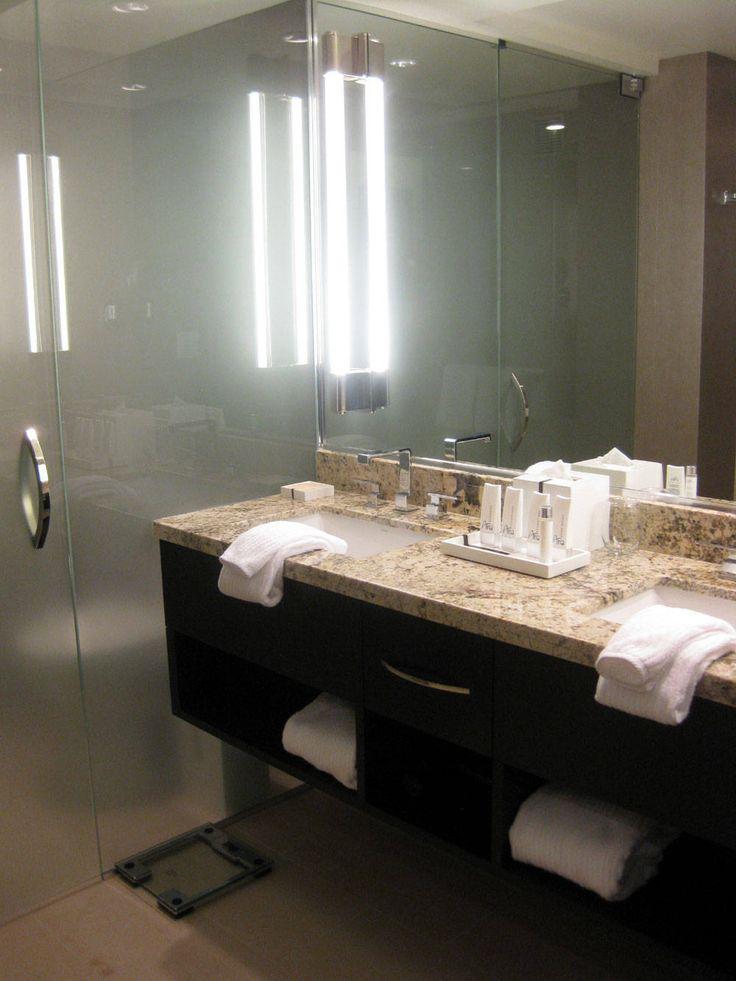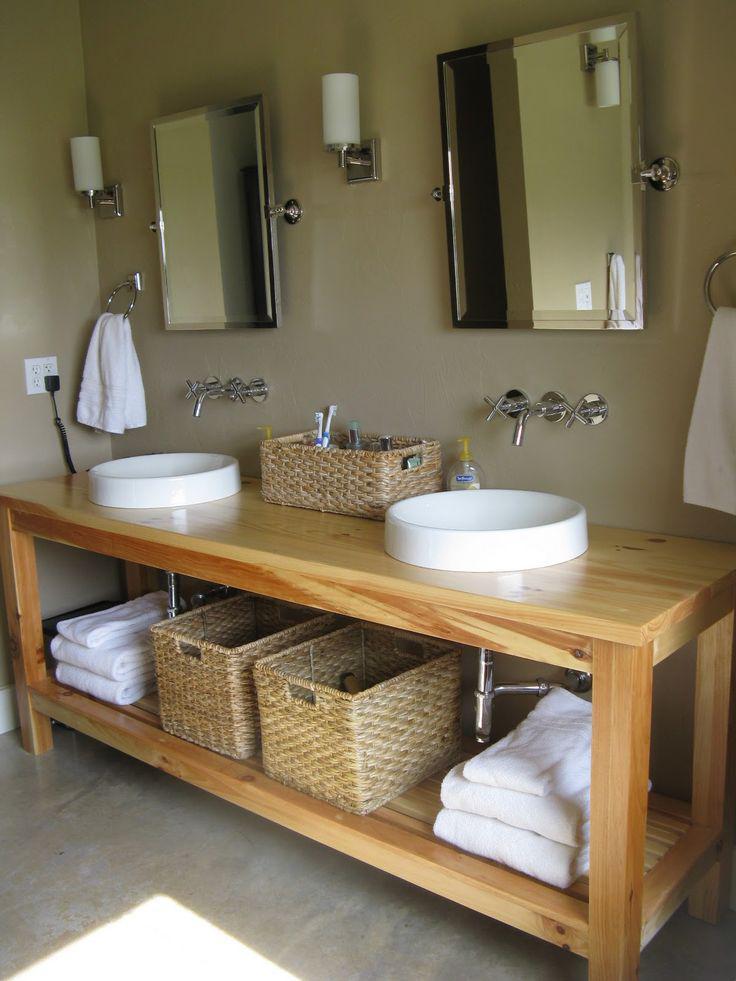The first image is the image on the left, the second image is the image on the right. For the images shown, is this caption "Left and right images each show one long counter with two separate sinks displayed at similar angles, and the counter on the right has at least one woven basket under it." true? Answer yes or no. Yes. The first image is the image on the left, the second image is the image on the right. Analyze the images presented: Is the assertion "In one image two vessel sinks are placed on a vanity with two stacks of white towels on a shelf below." valid? Answer yes or no. Yes. 